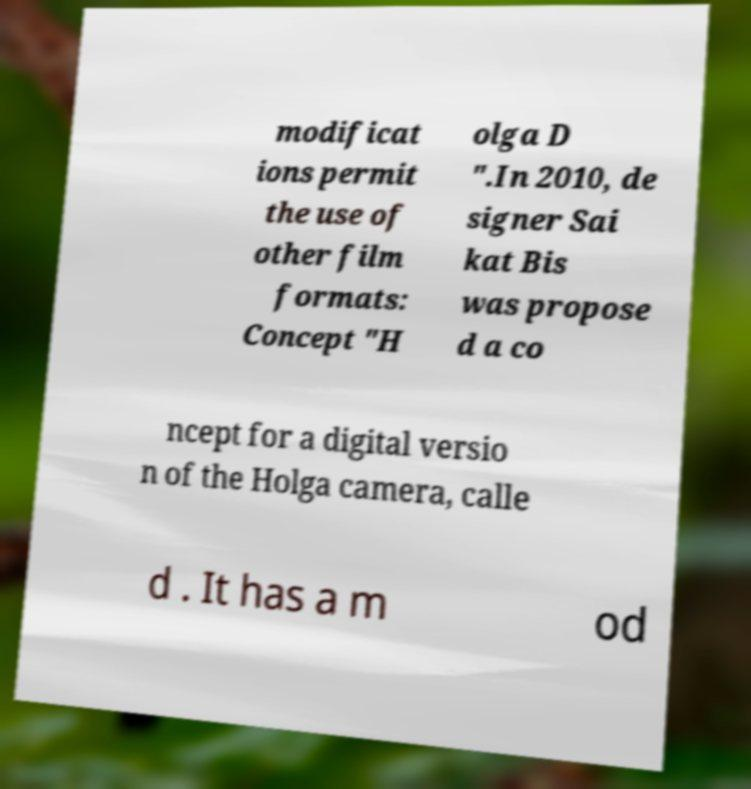Can you accurately transcribe the text from the provided image for me? modificat ions permit the use of other film formats: Concept "H olga D ".In 2010, de signer Sai kat Bis was propose d a co ncept for a digital versio n of the Holga camera, calle d . It has a m od 